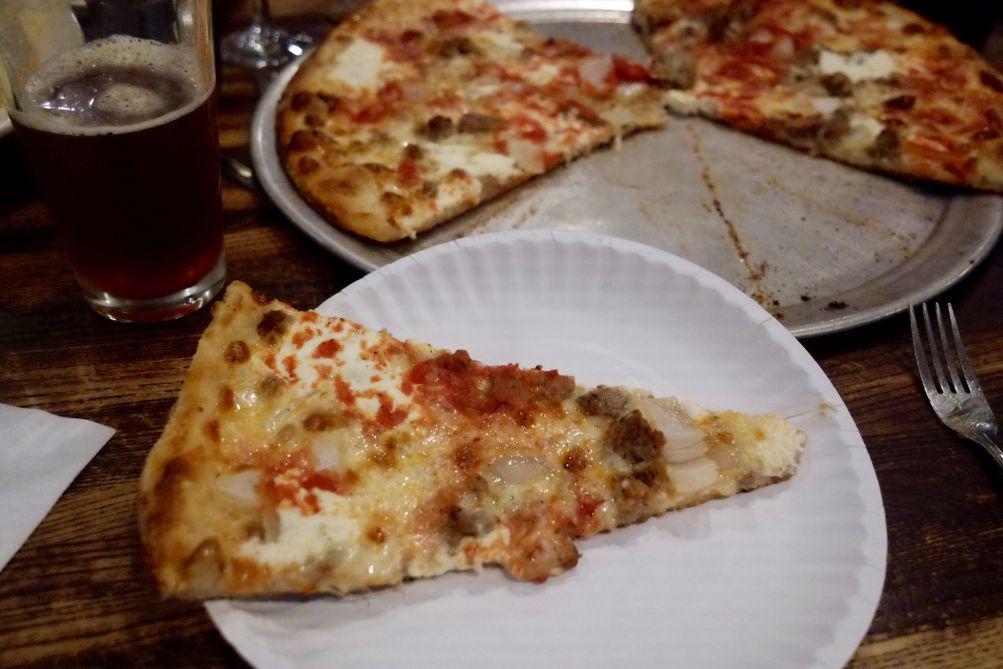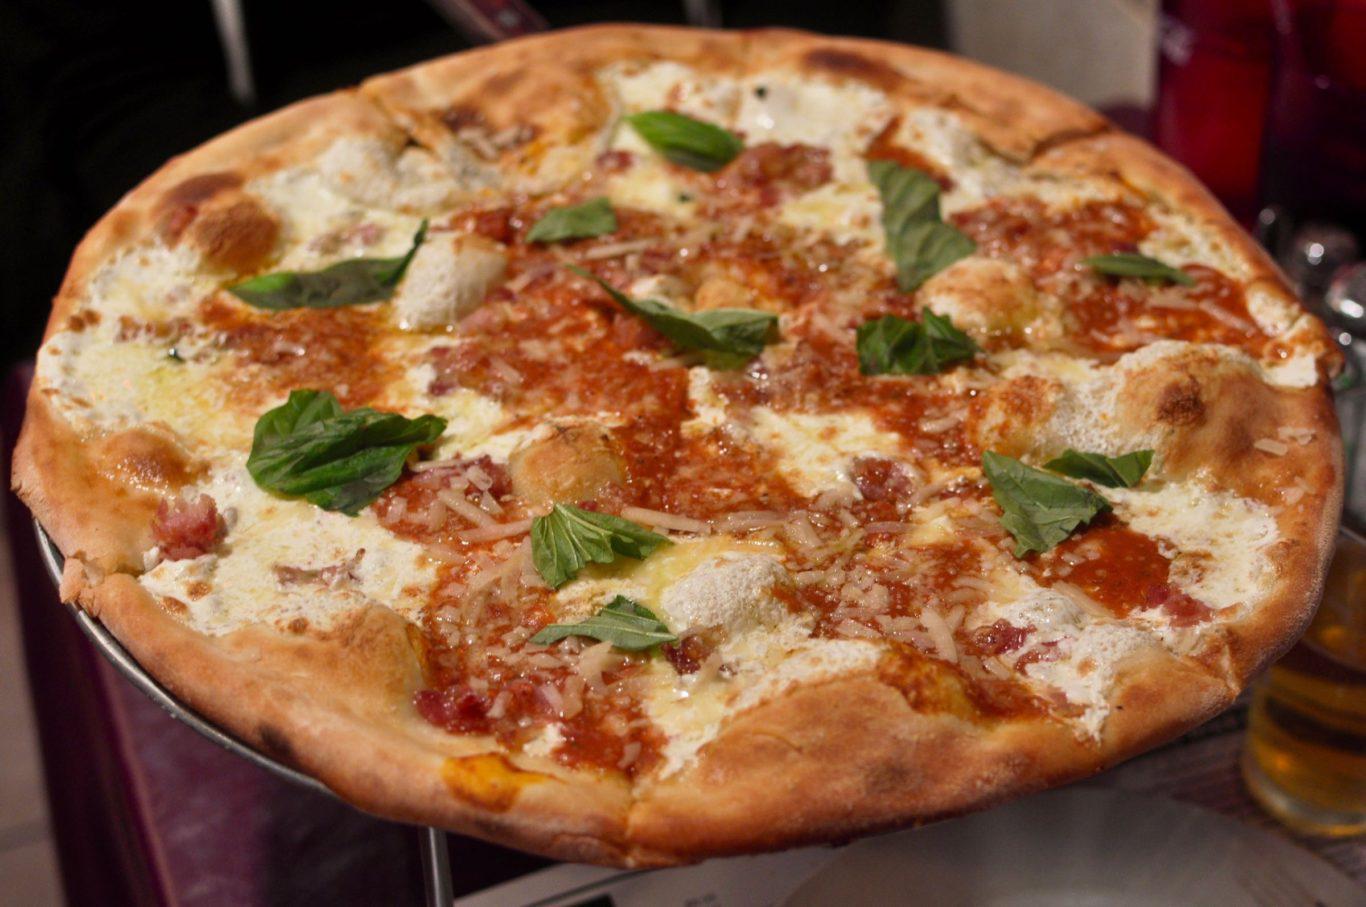The first image is the image on the left, the second image is the image on the right. Examine the images to the left and right. Is the description "A pizza in one image is intact, while a second image shows a slice of pizza and a paper plate." accurate? Answer yes or no. Yes. The first image is the image on the left, the second image is the image on the right. Given the left and right images, does the statement "The right image shows a whole pizza on a silver tray, and the left image shows one pizza slice on a white paper plate next to a silver tray containing less than a whole pizza." hold true? Answer yes or no. Yes. 